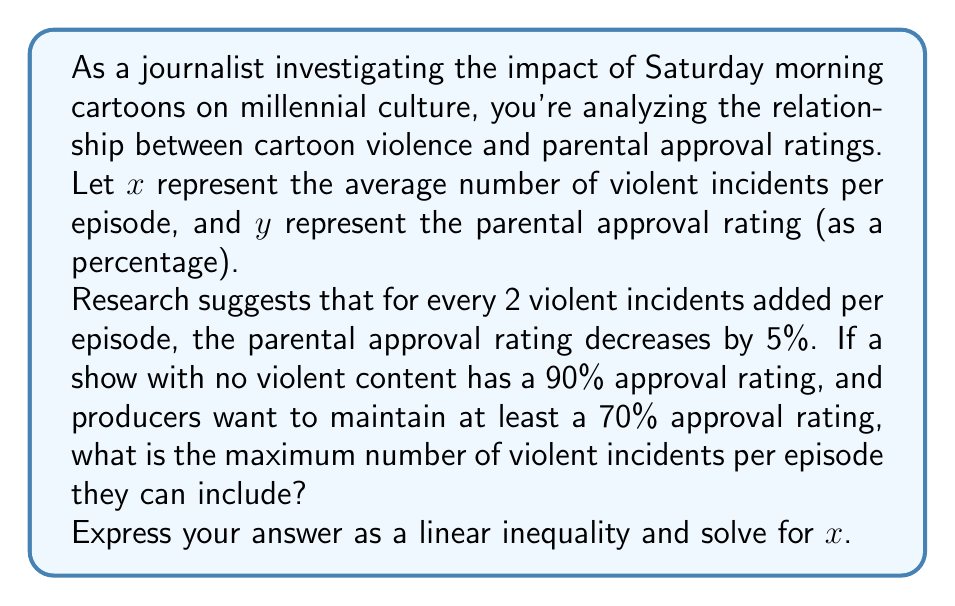Help me with this question. Let's approach this step-by-step:

1) First, we need to establish the linear relationship between $x$ and $y$:
   - When $x = 0$ (no violence), $y = 90$ (90% approval)
   - For every increase of 2 in $x$, $y$ decreases by 5

2) We can express this as a linear equation:
   $y = 90 - \frac{5}{2}x$

3) The producers want to maintain at least a 70% approval rating, so we can write this as an inequality:
   $y \geq 70$

4) Substituting our linear equation into this inequality:
   $90 - \frac{5}{2}x \geq 70$

5) Now, let's solve for $x$:
   $-\frac{5}{2}x \geq -20$
   $\frac{5}{2}x \leq 20$
   $x \leq 8$

6) Therefore, the maximum number of violent incidents per episode is 8.

7) To express this as a linear inequality in standard form:
   $x \leq 8$ or $-x \geq -8$
Answer: $-x \geq -8$ or $x \leq 8$
The maximum number of violent incidents per episode is 8. 